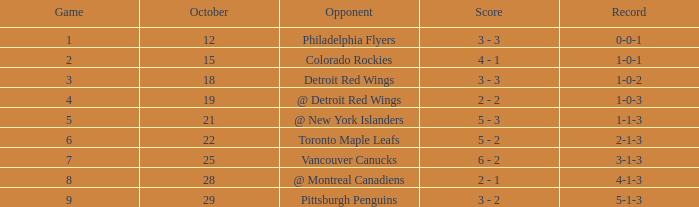What is the minimum game with a 5-1-3 record? 9.0. Could you help me parse every detail presented in this table? {'header': ['Game', 'October', 'Opponent', 'Score', 'Record'], 'rows': [['1', '12', 'Philadelphia Flyers', '3 - 3', '0-0-1'], ['2', '15', 'Colorado Rockies', '4 - 1', '1-0-1'], ['3', '18', 'Detroit Red Wings', '3 - 3', '1-0-2'], ['4', '19', '@ Detroit Red Wings', '2 - 2', '1-0-3'], ['5', '21', '@ New York Islanders', '5 - 3', '1-1-3'], ['6', '22', 'Toronto Maple Leafs', '5 - 2', '2-1-3'], ['7', '25', 'Vancouver Canucks', '6 - 2', '3-1-3'], ['8', '28', '@ Montreal Canadiens', '2 - 1', '4-1-3'], ['9', '29', 'Pittsburgh Penguins', '3 - 2', '5-1-3']]} 